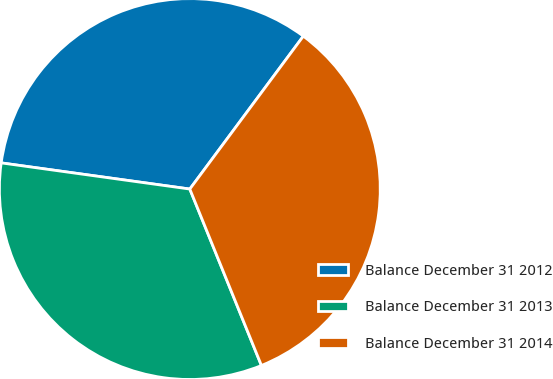Convert chart to OTSL. <chart><loc_0><loc_0><loc_500><loc_500><pie_chart><fcel>Balance December 31 2012<fcel>Balance December 31 2013<fcel>Balance December 31 2014<nl><fcel>32.97%<fcel>33.33%<fcel>33.7%<nl></chart> 